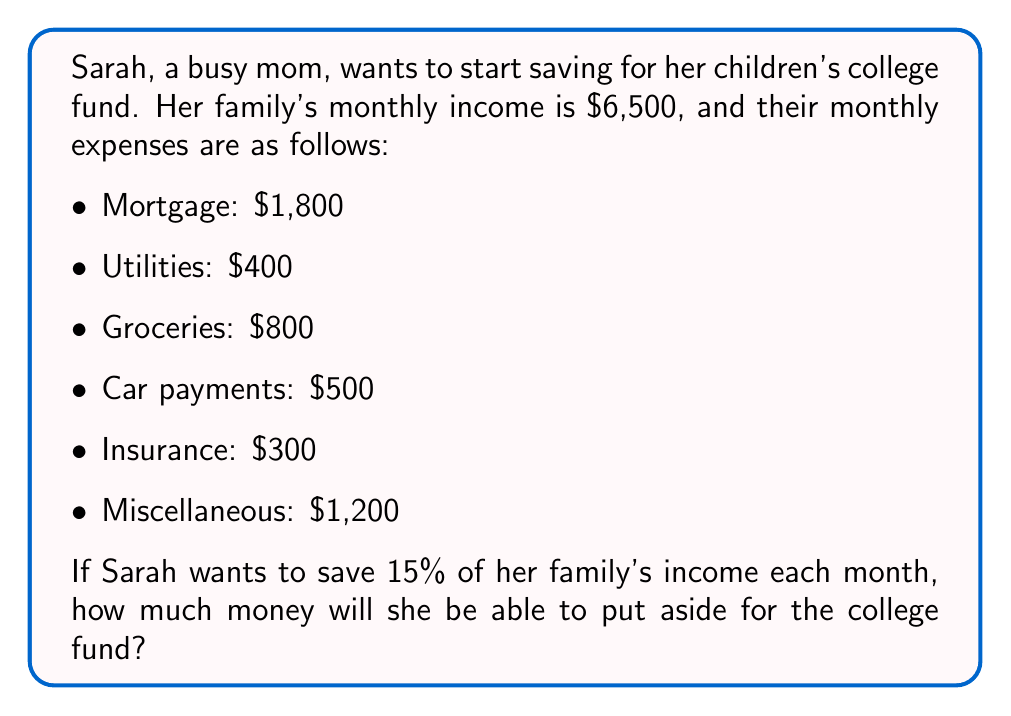Give your solution to this math problem. Let's approach this problem step-by-step:

1. Calculate the total monthly expenses:
   $$1800 + 400 + 800 + 500 + 300 + 1200 = $5000$$

2. Calculate the difference between income and expenses:
   $$6500 - 5000 = $1500$$
   This is the amount left after paying all expenses.

3. Calculate 15% of the monthly income:
   $$0.15 \times 6500 = $975$$
   This is the target amount Sarah wants to save.

4. Compare the amount left after expenses ($1500) with the target savings amount ($975):
   Since $1500 > $975, Sarah can achieve her savings goal.

5. The amount Sarah can put aside for the college fund is the target savings amount:
   $$975$$
Answer: $975 